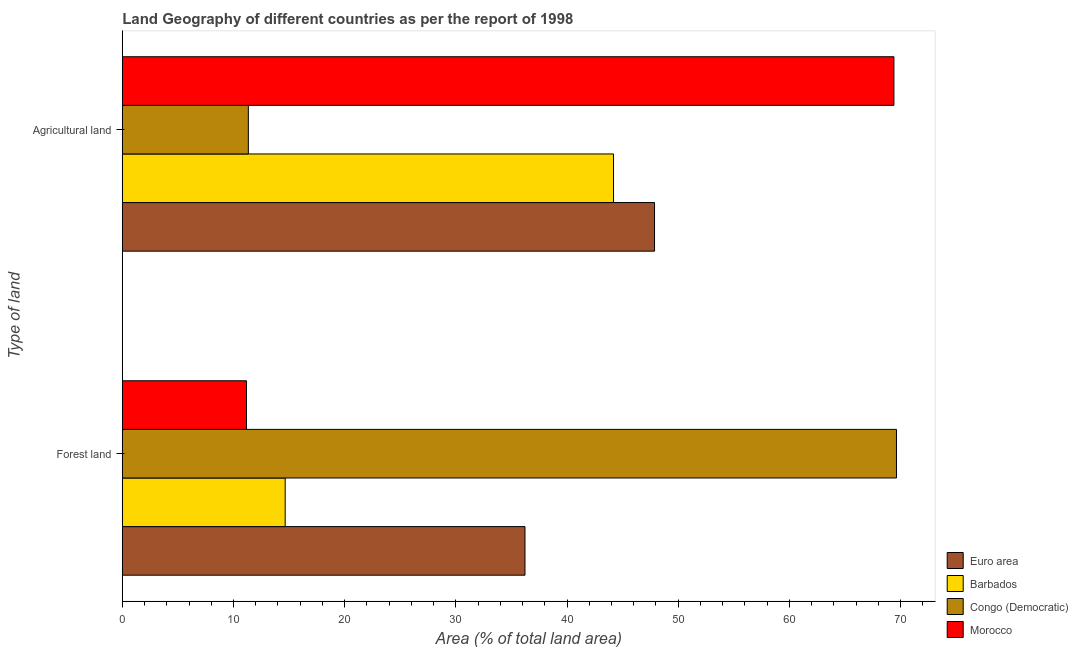Are the number of bars per tick equal to the number of legend labels?
Your answer should be very brief. Yes. Are the number of bars on each tick of the Y-axis equal?
Give a very brief answer. Yes. What is the label of the 1st group of bars from the top?
Provide a succinct answer. Agricultural land. What is the percentage of land area under forests in Barbados?
Your answer should be compact. 14.65. Across all countries, what is the maximum percentage of land area under agriculture?
Your answer should be very brief. 69.41. Across all countries, what is the minimum percentage of land area under agriculture?
Make the answer very short. 11.34. In which country was the percentage of land area under forests maximum?
Provide a short and direct response. Congo (Democratic). In which country was the percentage of land area under agriculture minimum?
Provide a short and direct response. Congo (Democratic). What is the total percentage of land area under agriculture in the graph?
Provide a succinct answer. 172.8. What is the difference between the percentage of land area under agriculture in Morocco and that in Congo (Democratic)?
Ensure brevity in your answer.  58.07. What is the difference between the percentage of land area under agriculture in Morocco and the percentage of land area under forests in Congo (Democratic)?
Offer a very short reply. -0.23. What is the average percentage of land area under agriculture per country?
Ensure brevity in your answer.  43.2. What is the difference between the percentage of land area under agriculture and percentage of land area under forests in Morocco?
Your response must be concise. 58.24. In how many countries, is the percentage of land area under agriculture greater than 36 %?
Your answer should be very brief. 3. What is the ratio of the percentage of land area under forests in Barbados to that in Morocco?
Ensure brevity in your answer.  1.31. What does the 1st bar from the top in Agricultural land represents?
Provide a short and direct response. Morocco. What does the 4th bar from the bottom in Agricultural land represents?
Offer a very short reply. Morocco. What is the difference between two consecutive major ticks on the X-axis?
Provide a succinct answer. 10. Does the graph contain any zero values?
Give a very brief answer. No. Does the graph contain grids?
Offer a terse response. No. Where does the legend appear in the graph?
Offer a very short reply. Bottom right. How many legend labels are there?
Your answer should be very brief. 4. What is the title of the graph?
Your response must be concise. Land Geography of different countries as per the report of 1998. What is the label or title of the X-axis?
Offer a terse response. Area (% of total land area). What is the label or title of the Y-axis?
Provide a succinct answer. Type of land. What is the Area (% of total land area) in Euro area in Forest land?
Offer a very short reply. 36.22. What is the Area (% of total land area) of Barbados in Forest land?
Offer a terse response. 14.65. What is the Area (% of total land area) of Congo (Democratic) in Forest land?
Your response must be concise. 69.64. What is the Area (% of total land area) of Morocco in Forest land?
Your answer should be very brief. 11.17. What is the Area (% of total land area) in Euro area in Agricultural land?
Keep it short and to the point. 47.87. What is the Area (% of total land area) in Barbados in Agricultural land?
Offer a terse response. 44.19. What is the Area (% of total land area) of Congo (Democratic) in Agricultural land?
Offer a very short reply. 11.34. What is the Area (% of total land area) of Morocco in Agricultural land?
Give a very brief answer. 69.41. Across all Type of land, what is the maximum Area (% of total land area) of Euro area?
Give a very brief answer. 47.87. Across all Type of land, what is the maximum Area (% of total land area) of Barbados?
Keep it short and to the point. 44.19. Across all Type of land, what is the maximum Area (% of total land area) of Congo (Democratic)?
Keep it short and to the point. 69.64. Across all Type of land, what is the maximum Area (% of total land area) in Morocco?
Provide a short and direct response. 69.41. Across all Type of land, what is the minimum Area (% of total land area) of Euro area?
Your answer should be very brief. 36.22. Across all Type of land, what is the minimum Area (% of total land area) of Barbados?
Your response must be concise. 14.65. Across all Type of land, what is the minimum Area (% of total land area) of Congo (Democratic)?
Your answer should be very brief. 11.34. Across all Type of land, what is the minimum Area (% of total land area) of Morocco?
Keep it short and to the point. 11.17. What is the total Area (% of total land area) in Euro area in the graph?
Ensure brevity in your answer.  84.09. What is the total Area (% of total land area) of Barbados in the graph?
Your answer should be compact. 58.84. What is the total Area (% of total land area) in Congo (Democratic) in the graph?
Provide a short and direct response. 80.97. What is the total Area (% of total land area) of Morocco in the graph?
Provide a succinct answer. 80.58. What is the difference between the Area (% of total land area) of Euro area in Forest land and that in Agricultural land?
Keep it short and to the point. -11.65. What is the difference between the Area (% of total land area) in Barbados in Forest land and that in Agricultural land?
Give a very brief answer. -29.53. What is the difference between the Area (% of total land area) in Congo (Democratic) in Forest land and that in Agricultural land?
Offer a very short reply. 58.3. What is the difference between the Area (% of total land area) of Morocco in Forest land and that in Agricultural land?
Keep it short and to the point. -58.24. What is the difference between the Area (% of total land area) in Euro area in Forest land and the Area (% of total land area) in Barbados in Agricultural land?
Your answer should be compact. -7.97. What is the difference between the Area (% of total land area) in Euro area in Forest land and the Area (% of total land area) in Congo (Democratic) in Agricultural land?
Offer a very short reply. 24.88. What is the difference between the Area (% of total land area) of Euro area in Forest land and the Area (% of total land area) of Morocco in Agricultural land?
Your answer should be compact. -33.19. What is the difference between the Area (% of total land area) in Barbados in Forest land and the Area (% of total land area) in Congo (Democratic) in Agricultural land?
Provide a succinct answer. 3.31. What is the difference between the Area (% of total land area) of Barbados in Forest land and the Area (% of total land area) of Morocco in Agricultural land?
Ensure brevity in your answer.  -54.76. What is the difference between the Area (% of total land area) of Congo (Democratic) in Forest land and the Area (% of total land area) of Morocco in Agricultural land?
Offer a terse response. 0.23. What is the average Area (% of total land area) of Euro area per Type of land?
Make the answer very short. 42.05. What is the average Area (% of total land area) of Barbados per Type of land?
Offer a very short reply. 29.42. What is the average Area (% of total land area) of Congo (Democratic) per Type of land?
Give a very brief answer. 40.49. What is the average Area (% of total land area) in Morocco per Type of land?
Keep it short and to the point. 40.29. What is the difference between the Area (% of total land area) of Euro area and Area (% of total land area) of Barbados in Forest land?
Offer a terse response. 21.57. What is the difference between the Area (% of total land area) of Euro area and Area (% of total land area) of Congo (Democratic) in Forest land?
Your answer should be compact. -33.42. What is the difference between the Area (% of total land area) in Euro area and Area (% of total land area) in Morocco in Forest land?
Provide a short and direct response. 25.05. What is the difference between the Area (% of total land area) of Barbados and Area (% of total land area) of Congo (Democratic) in Forest land?
Your response must be concise. -54.99. What is the difference between the Area (% of total land area) of Barbados and Area (% of total land area) of Morocco in Forest land?
Keep it short and to the point. 3.48. What is the difference between the Area (% of total land area) in Congo (Democratic) and Area (% of total land area) in Morocco in Forest land?
Your answer should be compact. 58.47. What is the difference between the Area (% of total land area) of Euro area and Area (% of total land area) of Barbados in Agricultural land?
Keep it short and to the point. 3.69. What is the difference between the Area (% of total land area) of Euro area and Area (% of total land area) of Congo (Democratic) in Agricultural land?
Offer a very short reply. 36.54. What is the difference between the Area (% of total land area) in Euro area and Area (% of total land area) in Morocco in Agricultural land?
Your answer should be very brief. -21.53. What is the difference between the Area (% of total land area) in Barbados and Area (% of total land area) in Congo (Democratic) in Agricultural land?
Make the answer very short. 32.85. What is the difference between the Area (% of total land area) of Barbados and Area (% of total land area) of Morocco in Agricultural land?
Ensure brevity in your answer.  -25.22. What is the difference between the Area (% of total land area) of Congo (Democratic) and Area (% of total land area) of Morocco in Agricultural land?
Make the answer very short. -58.07. What is the ratio of the Area (% of total land area) of Euro area in Forest land to that in Agricultural land?
Give a very brief answer. 0.76. What is the ratio of the Area (% of total land area) in Barbados in Forest land to that in Agricultural land?
Offer a very short reply. 0.33. What is the ratio of the Area (% of total land area) of Congo (Democratic) in Forest land to that in Agricultural land?
Offer a terse response. 6.14. What is the ratio of the Area (% of total land area) in Morocco in Forest land to that in Agricultural land?
Your answer should be very brief. 0.16. What is the difference between the highest and the second highest Area (% of total land area) of Euro area?
Ensure brevity in your answer.  11.65. What is the difference between the highest and the second highest Area (% of total land area) in Barbados?
Provide a succinct answer. 29.53. What is the difference between the highest and the second highest Area (% of total land area) in Congo (Democratic)?
Your answer should be compact. 58.3. What is the difference between the highest and the second highest Area (% of total land area) in Morocco?
Make the answer very short. 58.24. What is the difference between the highest and the lowest Area (% of total land area) of Euro area?
Your answer should be very brief. 11.65. What is the difference between the highest and the lowest Area (% of total land area) of Barbados?
Offer a terse response. 29.53. What is the difference between the highest and the lowest Area (% of total land area) of Congo (Democratic)?
Provide a succinct answer. 58.3. What is the difference between the highest and the lowest Area (% of total land area) of Morocco?
Your response must be concise. 58.24. 